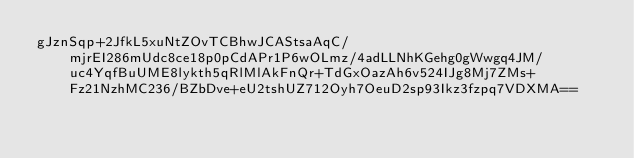Convert code to text. <code><loc_0><loc_0><loc_500><loc_500><_SML_>gJznSqp+2JfkL5xuNtZOvTCBhwJCAStsaAqC/mjrEI286mUdc8ce18p0pCdAPr1P6wOLmz/4adLLNhKGehg0gWwgq4JM/uc4YqfBuUME8lykth5qRlMlAkFnQr+TdGxOazAh6v524IJg8Mj7ZMs+Fz21NzhMC236/BZbDve+eU2tshUZ712Oyh7OeuD2sp93Ikz3fzpq7VDXMA==</code> 